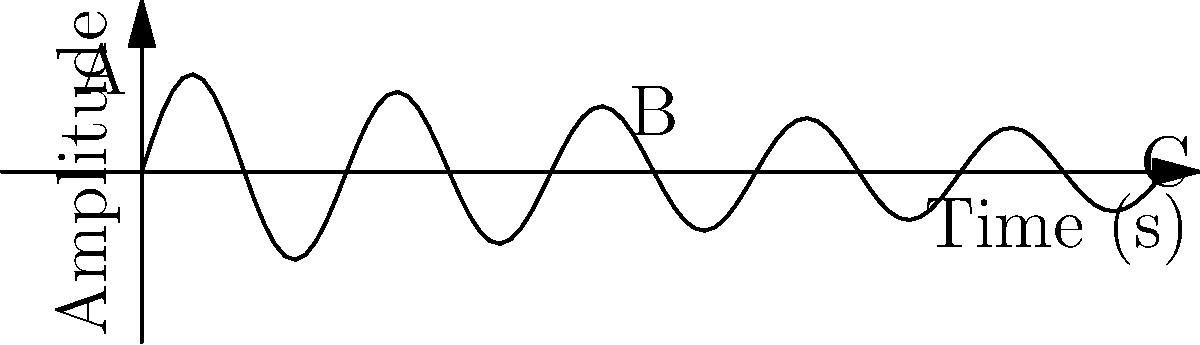As an independent artist inspired by Anesha & Antea Birchett, you're analyzing the frequency spectrum of a musical composition. The graph shows the waveform of a single note. What does the gradual decrease in amplitude from point A to C indicate about the sound's characteristics over time? To analyze this waveform and understand its implications for the frequency spectrum:

1. Observe the overall shape: The amplitude decreases over time while maintaining a sinusoidal pattern.

2. Identify the envelope: The curve connecting points A, B, and C forms a decaying exponential envelope.

3. Understand the envelope's meaning: This envelope represents the gradual decrease in the sound's intensity over time.

4. Relate to sound characteristics:
   a) Attack: Not visible in this graph (would be the initial rise in amplitude).
   b) Decay: The rapid initial decrease from A to B.
   c) Sustain: The more gradual decrease from B to C.
   d) Release: The final tapering off after C (not fully shown).

5. Frequency content: The consistent oscillation indicates a dominant frequency throughout.

6. Timbre implication: The smooth decay suggests a relatively simple harmonic structure, typical of a plucked string or struck bell.

7. Spectral evolution: As the amplitude decreases, higher harmonics typically decay faster than the fundamental frequency, resulting in a gradual simplification of the frequency spectrum over time.

This gradual amplitude decrease indicates a natural decay in the sound's intensity and richness over time, a characteristic often associated with acoustic instruments or well-designed synthesizer patches.
Answer: Natural decay of sound intensity and spectral richness 